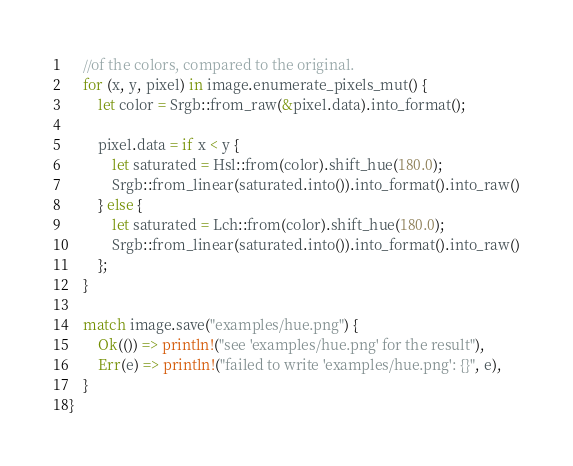<code> <loc_0><loc_0><loc_500><loc_500><_Rust_>    //of the colors, compared to the original.
    for (x, y, pixel) in image.enumerate_pixels_mut() {
        let color = Srgb::from_raw(&pixel.data).into_format();

        pixel.data = if x < y {
            let saturated = Hsl::from(color).shift_hue(180.0);
            Srgb::from_linear(saturated.into()).into_format().into_raw()
        } else {
            let saturated = Lch::from(color).shift_hue(180.0);
            Srgb::from_linear(saturated.into()).into_format().into_raw()
        };
    }

    match image.save("examples/hue.png") {
        Ok(()) => println!("see 'examples/hue.png' for the result"),
        Err(e) => println!("failed to write 'examples/hue.png': {}", e),
    }
}
</code> 